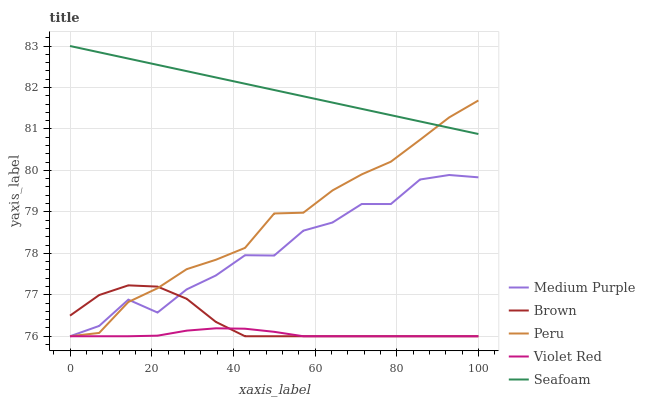Does Violet Red have the minimum area under the curve?
Answer yes or no. Yes. Does Seafoam have the maximum area under the curve?
Answer yes or no. Yes. Does Brown have the minimum area under the curve?
Answer yes or no. No. Does Brown have the maximum area under the curve?
Answer yes or no. No. Is Seafoam the smoothest?
Answer yes or no. Yes. Is Medium Purple the roughest?
Answer yes or no. Yes. Is Brown the smoothest?
Answer yes or no. No. Is Brown the roughest?
Answer yes or no. No. Does Seafoam have the lowest value?
Answer yes or no. No. Does Brown have the highest value?
Answer yes or no. No. Is Violet Red less than Seafoam?
Answer yes or no. Yes. Is Seafoam greater than Medium Purple?
Answer yes or no. Yes. Does Violet Red intersect Seafoam?
Answer yes or no. No. 